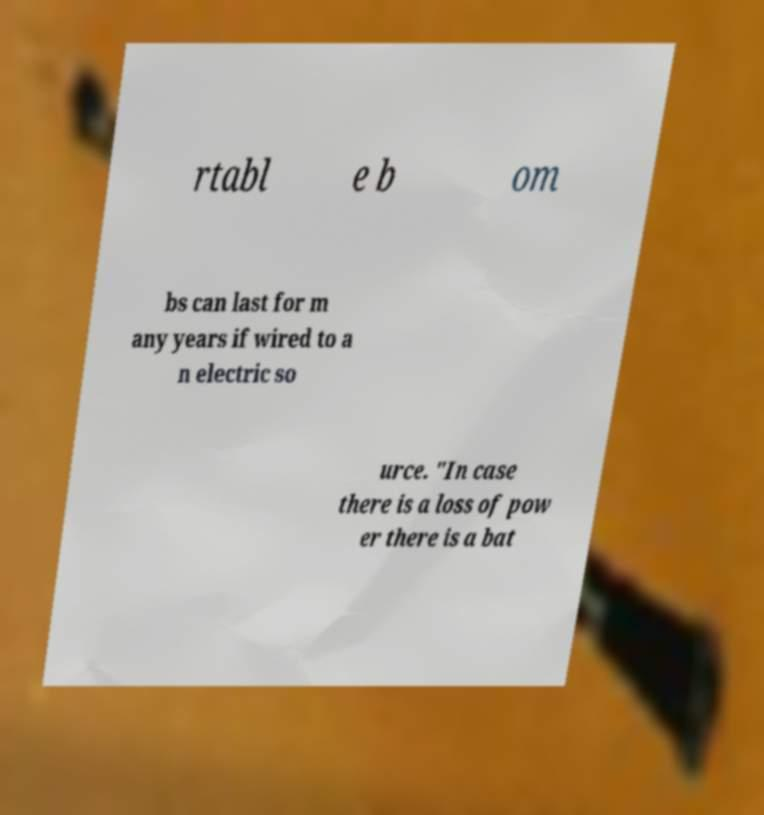Can you accurately transcribe the text from the provided image for me? rtabl e b om bs can last for m any years if wired to a n electric so urce. "In case there is a loss of pow er there is a bat 